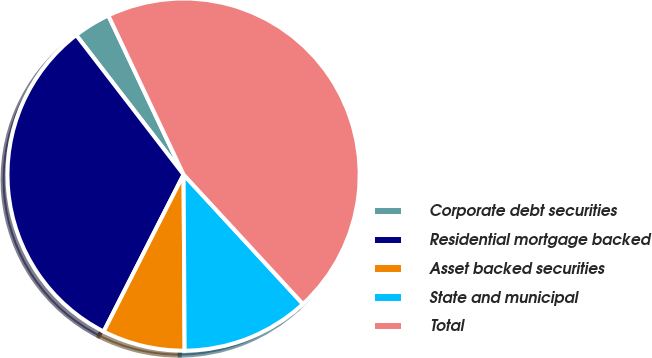Convert chart. <chart><loc_0><loc_0><loc_500><loc_500><pie_chart><fcel>Corporate debt securities<fcel>Residential mortgage backed<fcel>Asset backed securities<fcel>State and municipal<fcel>Total<nl><fcel>3.41%<fcel>32.06%<fcel>7.59%<fcel>11.76%<fcel>45.17%<nl></chart> 